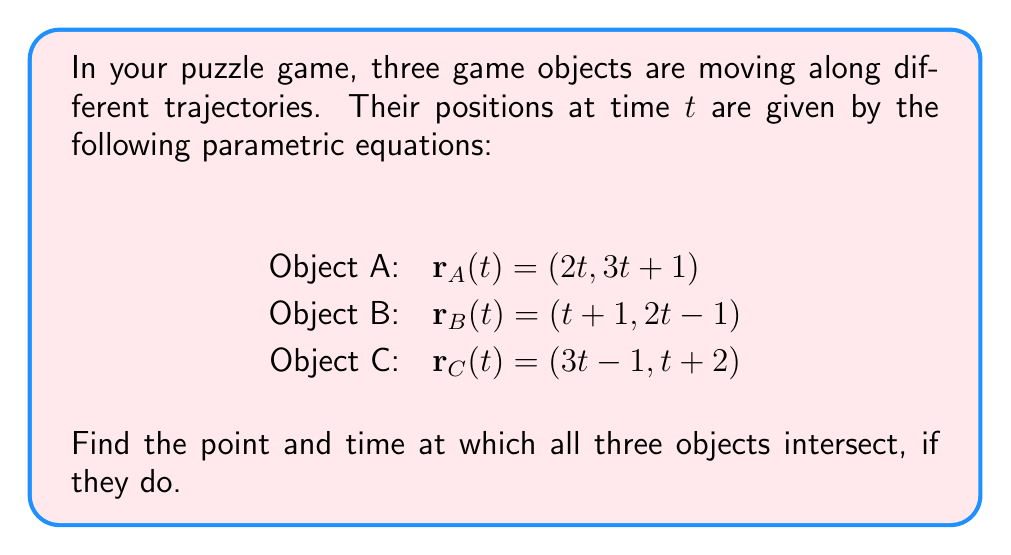Can you solve this math problem? To find the intersection point, we need to solve the system of equations where all three position vectors are equal:

$$\mathbf{r}_A(t_1) = \mathbf{r}_B(t_2) = \mathbf{r}_C(t_3)$$

This gives us:

$$(2t_1, 3t_1 + 1) = (t_2 + 1, 2t_2 - 1) = (3t_3 - 1, t_3 + 2)$$

Equating the x-coordinates:
$$2t_1 = t_2 + 1 = 3t_3 - 1$$

Equating the y-coordinates:
$$3t_1 + 1 = 2t_2 - 1 = t_3 + 2$$

From the x-coordinates:
$$t_2 = 2t_1 - 1 \text{ and } t_3 = \frac{2t_1 + 1}{3}$$

Substituting these into the y-coordinate equations:

$$3t_1 + 1 = 2(2t_1 - 1) - 1 = \frac{2t_1 + 1}{3} + 2$$

Simplifying the first equation:
$$3t_1 + 1 = 4t_1 - 3$$
$$4 = t_1$$

Checking if this satisfies the second equation:
$$3(4) + 1 = \frac{2(4) + 1}{3} + 2$$
$$13 = \frac{9}{3} + 2 = 5$$

Since this is true, we have found the solution. The time of intersection is $t_1 = t_2 = t_3 = 4$.

To find the intersection point, we can substitute $t = 4$ into any of the original equations:

$$\mathbf{r}_A(4) = (2(4), 3(4) + 1) = (8, 13)$$

Therefore, the objects intersect at the point (8, 13) at time t = 4.
Answer: (8, 13) at t = 4 